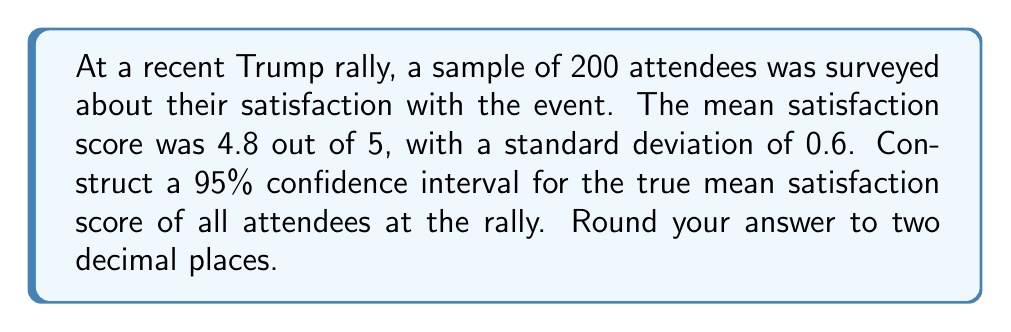Could you help me with this problem? Let's approach this step-by-step:

1) We're given:
   - Sample size (n) = 200
   - Sample mean (x̄) = 4.8
   - Sample standard deviation (s) = 0.6
   - Confidence level = 95%

2) For a 95% confidence interval, we use a z-score of 1.96.

3) The formula for the confidence interval is:

   $$\text{CI} = \bar{x} \pm z \cdot \frac{s}{\sqrt{n}}$$

4) Let's calculate the margin of error:

   $$\text{Margin of Error} = 1.96 \cdot \frac{0.6}{\sqrt{200}} = 1.96 \cdot \frac{0.6}{14.14} = 0.0831$$

5) Now, we can calculate the confidence interval:

   Lower bound: $4.8 - 0.0831 = 4.7169$
   Upper bound: $4.8 + 0.0831 = 4.8831$

6) Rounding to two decimal places:

   CI = (4.72, 4.88)

This means we can be 95% confident that the true mean satisfaction score for all attendees at the Trump rally falls between 4.72 and 4.88.
Answer: (4.72, 4.88) 